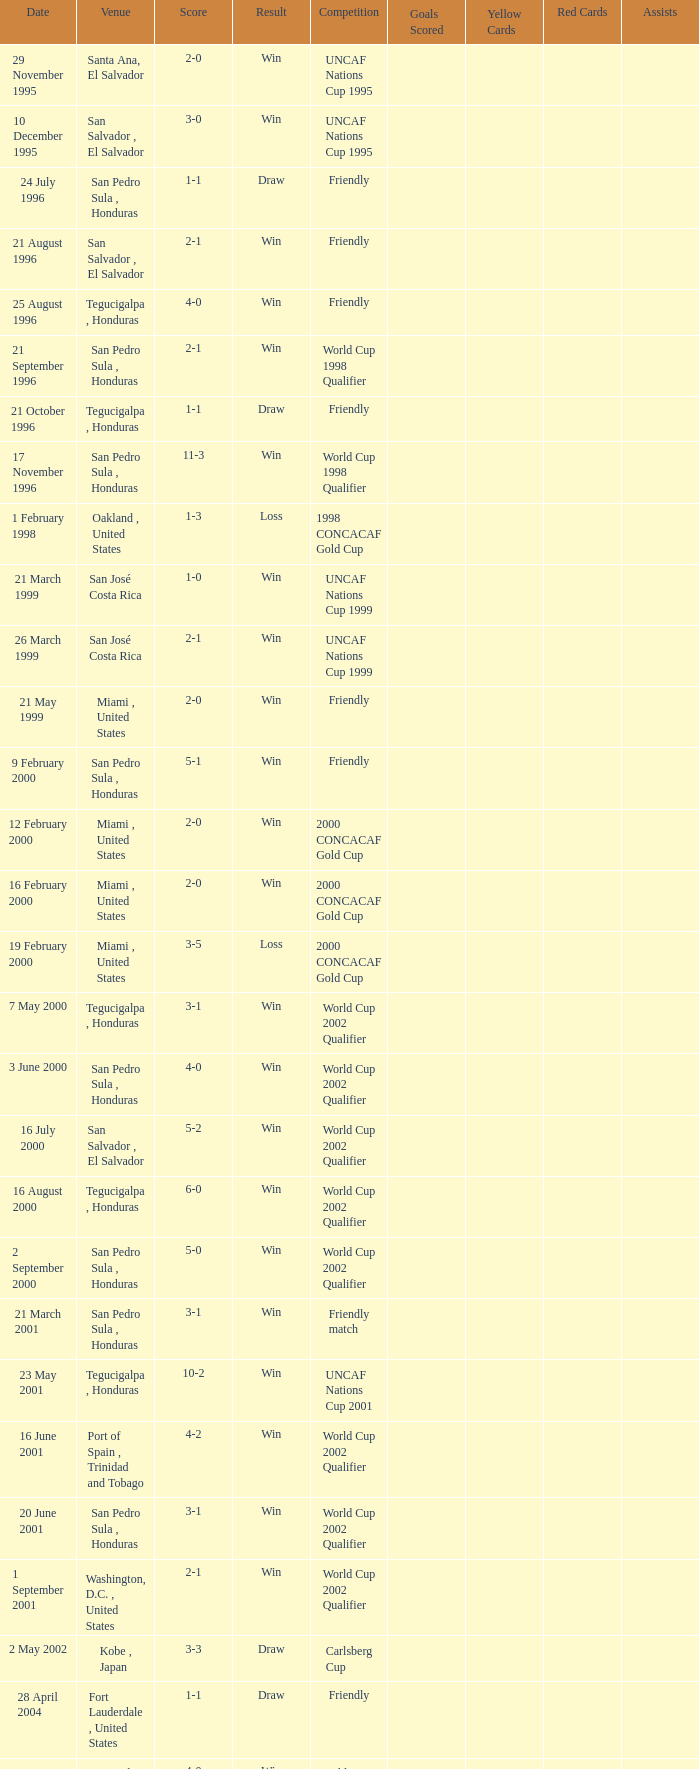Name the date of the uncaf nations cup 2009 26 January 2009. Can you give me this table as a dict? {'header': ['Date', 'Venue', 'Score', 'Result', 'Competition', 'Goals Scored', 'Yellow Cards', 'Red Cards', 'Assists'], 'rows': [['29 November 1995', 'Santa Ana, El Salvador', '2-0', 'Win', 'UNCAF Nations Cup 1995', '', '', '', ''], ['10 December 1995', 'San Salvador , El Salvador', '3-0', 'Win', 'UNCAF Nations Cup 1995', '', '', '', ''], ['24 July 1996', 'San Pedro Sula , Honduras', '1-1', 'Draw', 'Friendly', '', '', '', ''], ['21 August 1996', 'San Salvador , El Salvador', '2-1', 'Win', 'Friendly', '', '', '', ''], ['25 August 1996', 'Tegucigalpa , Honduras', '4-0', 'Win', 'Friendly', '', '', '', ''], ['21 September 1996', 'San Pedro Sula , Honduras', '2-1', 'Win', 'World Cup 1998 Qualifier', '', '', '', ''], ['21 October 1996', 'Tegucigalpa , Honduras', '1-1', 'Draw', 'Friendly', '', '', '', ''], ['17 November 1996', 'San Pedro Sula , Honduras', '11-3', 'Win', 'World Cup 1998 Qualifier', '', '', '', ''], ['1 February 1998', 'Oakland , United States', '1-3', 'Loss', '1998 CONCACAF Gold Cup', '', '', '', ''], ['21 March 1999', 'San José Costa Rica', '1-0', 'Win', 'UNCAF Nations Cup 1999', '', '', '', ''], ['26 March 1999', 'San José Costa Rica', '2-1', 'Win', 'UNCAF Nations Cup 1999', '', '', '', ''], ['21 May 1999', 'Miami , United States', '2-0', 'Win', 'Friendly', '', '', '', ''], ['9 February 2000', 'San Pedro Sula , Honduras', '5-1', 'Win', 'Friendly', '', '', '', ''], ['12 February 2000', 'Miami , United States', '2-0', 'Win', '2000 CONCACAF Gold Cup', '', '', '', ''], ['16 February 2000', 'Miami , United States', '2-0', 'Win', '2000 CONCACAF Gold Cup', '', '', '', ''], ['19 February 2000', 'Miami , United States', '3-5', 'Loss', '2000 CONCACAF Gold Cup', '', '', '', ''], ['7 May 2000', 'Tegucigalpa , Honduras', '3-1', 'Win', 'World Cup 2002 Qualifier', '', '', '', ''], ['3 June 2000', 'San Pedro Sula , Honduras', '4-0', 'Win', 'World Cup 2002 Qualifier', '', '', '', ''], ['16 July 2000', 'San Salvador , El Salvador', '5-2', 'Win', 'World Cup 2002 Qualifier', '', '', '', ''], ['16 August 2000', 'Tegucigalpa , Honduras', '6-0', 'Win', 'World Cup 2002 Qualifier', '', '', '', ''], ['2 September 2000', 'San Pedro Sula , Honduras', '5-0', 'Win', 'World Cup 2002 Qualifier', '', '', '', ''], ['21 March 2001', 'San Pedro Sula , Honduras', '3-1', 'Win', 'Friendly match', '', '', '', ''], ['23 May 2001', 'Tegucigalpa , Honduras', '10-2', 'Win', 'UNCAF Nations Cup 2001', '', '', '', ''], ['16 June 2001', 'Port of Spain , Trinidad and Tobago', '4-2', 'Win', 'World Cup 2002 Qualifier', '', '', '', ''], ['20 June 2001', 'San Pedro Sula , Honduras', '3-1', 'Win', 'World Cup 2002 Qualifier', '', '', '', ''], ['1 September 2001', 'Washington, D.C. , United States', '2-1', 'Win', 'World Cup 2002 Qualifier', '', '', '', ''], ['2 May 2002', 'Kobe , Japan', '3-3', 'Draw', 'Carlsberg Cup', '', '', '', ''], ['28 April 2004', 'Fort Lauderdale , United States', '1-1', 'Draw', 'Friendly', '', '', '', ''], ['19 June 2004', 'San Pedro Sula , Honduras', '4-0', 'Win', 'World Cup 2006 Qualification', '', '', '', ''], ['19 April 2007', 'La Ceiba , Honduras', '1-3', 'Loss', 'Friendly', '', '', '', ''], ['25 May 2007', 'Mérida , Venezuela', '1-2', 'Loss', 'Friendly', '', '', '', ''], ['13 June 2007', 'Houston , United States', '5-0', 'Win', '2007 CONCACAF Gold Cup', '', '', '', ''], ['17 June 2007', 'Houston , United States', '1-2', 'Loss', '2007 CONCACAF Gold Cup', '', '', '', ''], ['18 January 2009', 'Miami , United States', '2-0', 'Win', 'Friendly', '', '', '', ''], ['26 January 2009', 'Tegucigalpa , Honduras', '2-0', 'Win', 'UNCAF Nations Cup 2009', '', '', '', ''], ['28 March 2009', 'Port of Spain , Trinidad and Tobago', '1-1', 'Draw', 'World Cup 2010 Qualification', '', '', '', ''], ['1 April 2009', 'San Pedro Sula , Honduras', '3-1', 'Win', 'World Cup 2010 Qualification', '', '', '', ''], ['10 June 2009', 'San Pedro Sula , Honduras', '1-0', 'Win', 'World Cup 2010 Qualification', '', '', '', ''], ['12 August 2009', 'San Pedro Sula , Honduras', '4-0', 'Win', 'World Cup 2010 Qualification', '', '', '', ''], ['5 September 2009', 'San Pedro Sula , Honduras', '4-1', 'Win', 'World Cup 2010 Qualification', '', '', '', ''], ['14 October 2009', 'San Salvador , El Salvador', '1-0', 'Win', 'World Cup 2010 Qualification', '', '', '', ''], ['23 January 2010', 'Carson , United States', '3-1', 'Win', 'Friendly', '', '', '', '']]} 